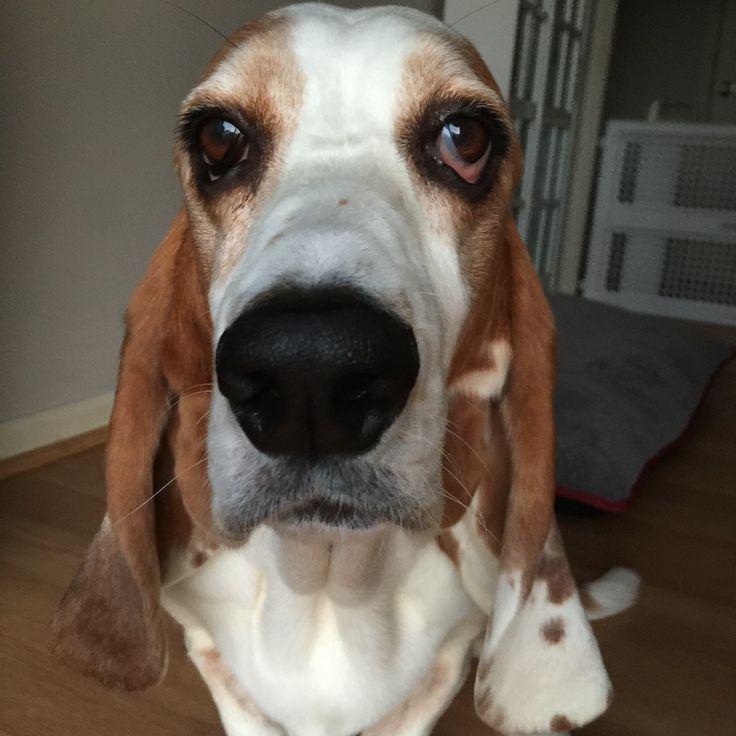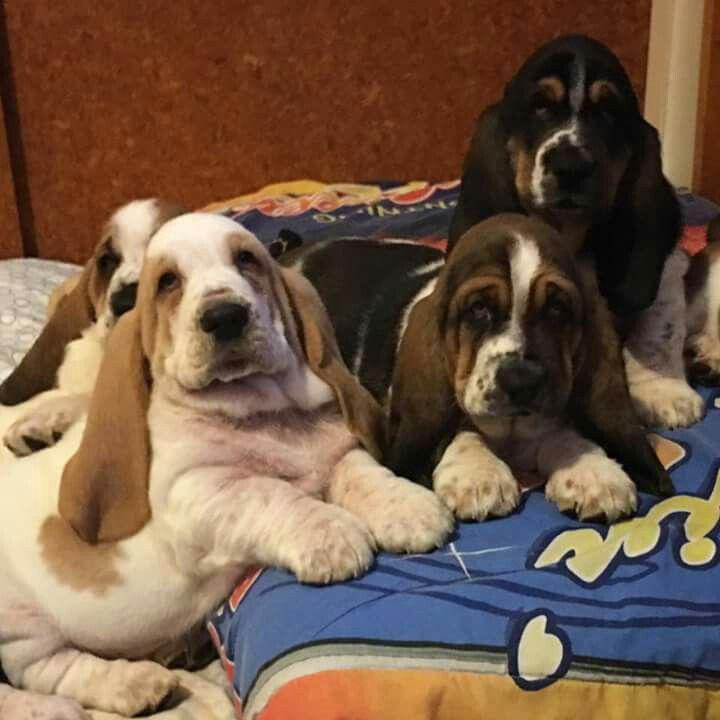The first image is the image on the left, the second image is the image on the right. Analyze the images presented: Is the assertion "There is at least two dogs in the right image." valid? Answer yes or no. Yes. 